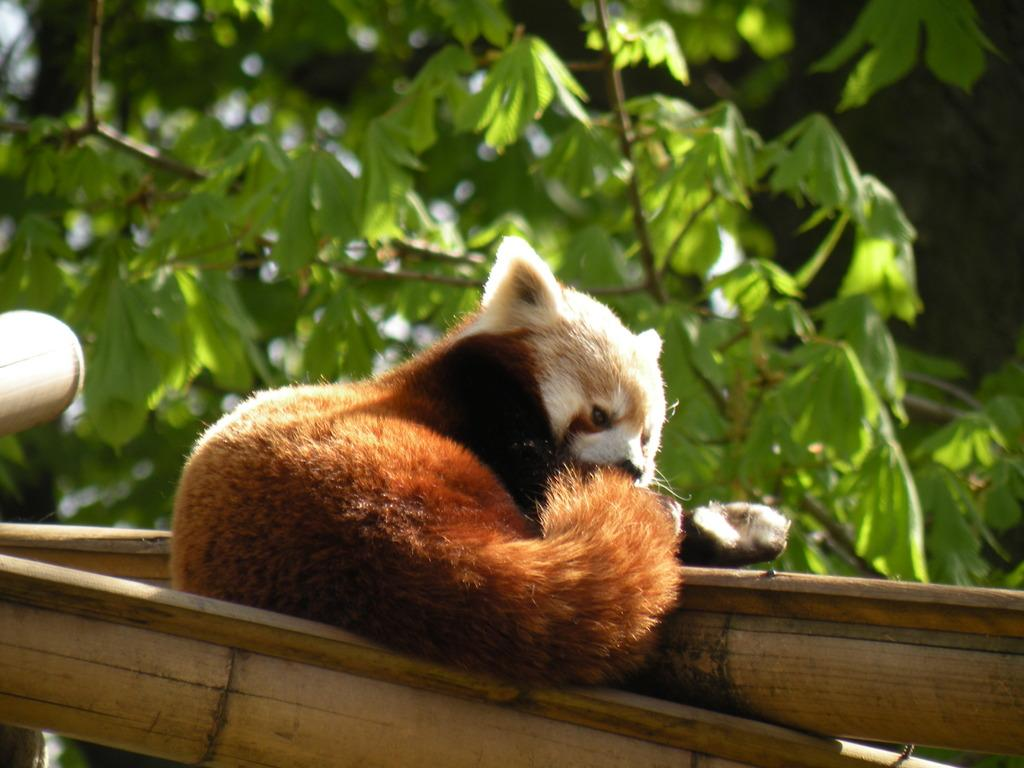What type of animal can be seen in the image? There is an animal in the image, but its specific type cannot be determined from the provided facts. How can the coloring of the animal be described? The animal has white and brown coloring. What is the animal standing on in the image? The animal is on wooden logs. What can be seen in the background of the image? There are many trees in the background of the image. What type of scarf is the animal wearing in the image? There is no scarf present in the image; the animal is not wearing any clothing. Can you tell me how many rays of sunlight are visible in the image? There is no mention of sunlight or rays in the provided facts, so we cannot determine the number of rays visible in the image. 